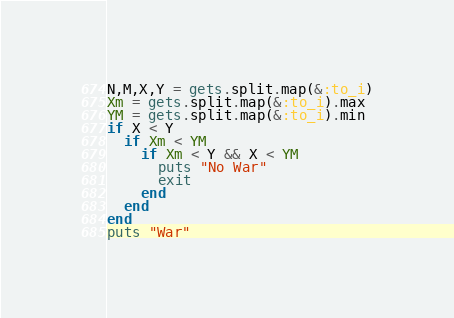<code> <loc_0><loc_0><loc_500><loc_500><_Ruby_>N,M,X,Y = gets.split.map(&:to_i)
Xm = gets.split.map(&:to_i).max
YM = gets.split.map(&:to_i).min
if X < Y
  if Xm < YM
    if Xm < Y && X < YM
      puts "No War"
      exit
    end
  end
end
puts "War"
</code> 